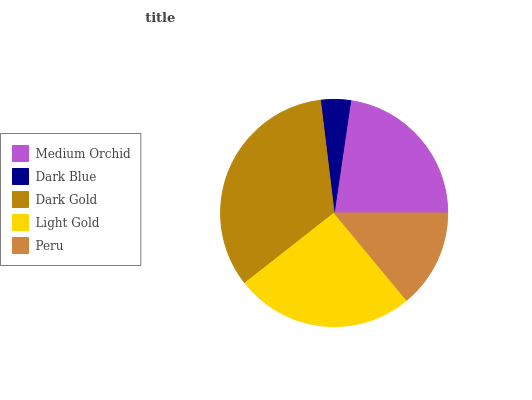Is Dark Blue the minimum?
Answer yes or no. Yes. Is Dark Gold the maximum?
Answer yes or no. Yes. Is Dark Gold the minimum?
Answer yes or no. No. Is Dark Blue the maximum?
Answer yes or no. No. Is Dark Gold greater than Dark Blue?
Answer yes or no. Yes. Is Dark Blue less than Dark Gold?
Answer yes or no. Yes. Is Dark Blue greater than Dark Gold?
Answer yes or no. No. Is Dark Gold less than Dark Blue?
Answer yes or no. No. Is Medium Orchid the high median?
Answer yes or no. Yes. Is Medium Orchid the low median?
Answer yes or no. Yes. Is Dark Blue the high median?
Answer yes or no. No. Is Peru the low median?
Answer yes or no. No. 